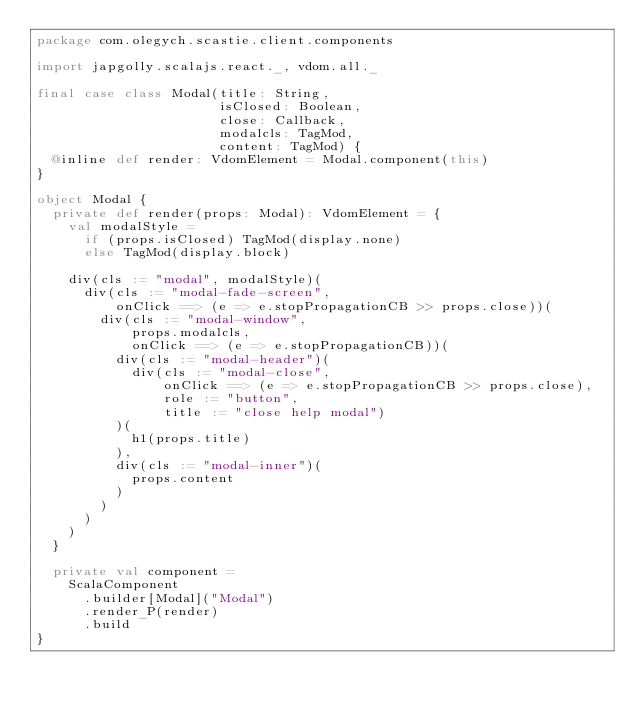<code> <loc_0><loc_0><loc_500><loc_500><_Scala_>package com.olegych.scastie.client.components

import japgolly.scalajs.react._, vdom.all._

final case class Modal(title: String,
                       isClosed: Boolean,
                       close: Callback,
                       modalcls: TagMod,
                       content: TagMod) {
  @inline def render: VdomElement = Modal.component(this)
}

object Modal {
  private def render(props: Modal): VdomElement = {
    val modalStyle =
      if (props.isClosed) TagMod(display.none)
      else TagMod(display.block)

    div(cls := "modal", modalStyle)(
      div(cls := "modal-fade-screen",
          onClick ==> (e => e.stopPropagationCB >> props.close))(
        div(cls := "modal-window",
            props.modalcls,
            onClick ==> (e => e.stopPropagationCB))(
          div(cls := "modal-header")(
            div(cls := "modal-close",
                onClick ==> (e => e.stopPropagationCB >> props.close),
                role := "button",
                title := "close help modal")
          )(
            h1(props.title)
          ),
          div(cls := "modal-inner")(
            props.content
          )
        )
      )
    )
  }

  private val component =
    ScalaComponent
      .builder[Modal]("Modal")
      .render_P(render)
      .build
}
</code> 